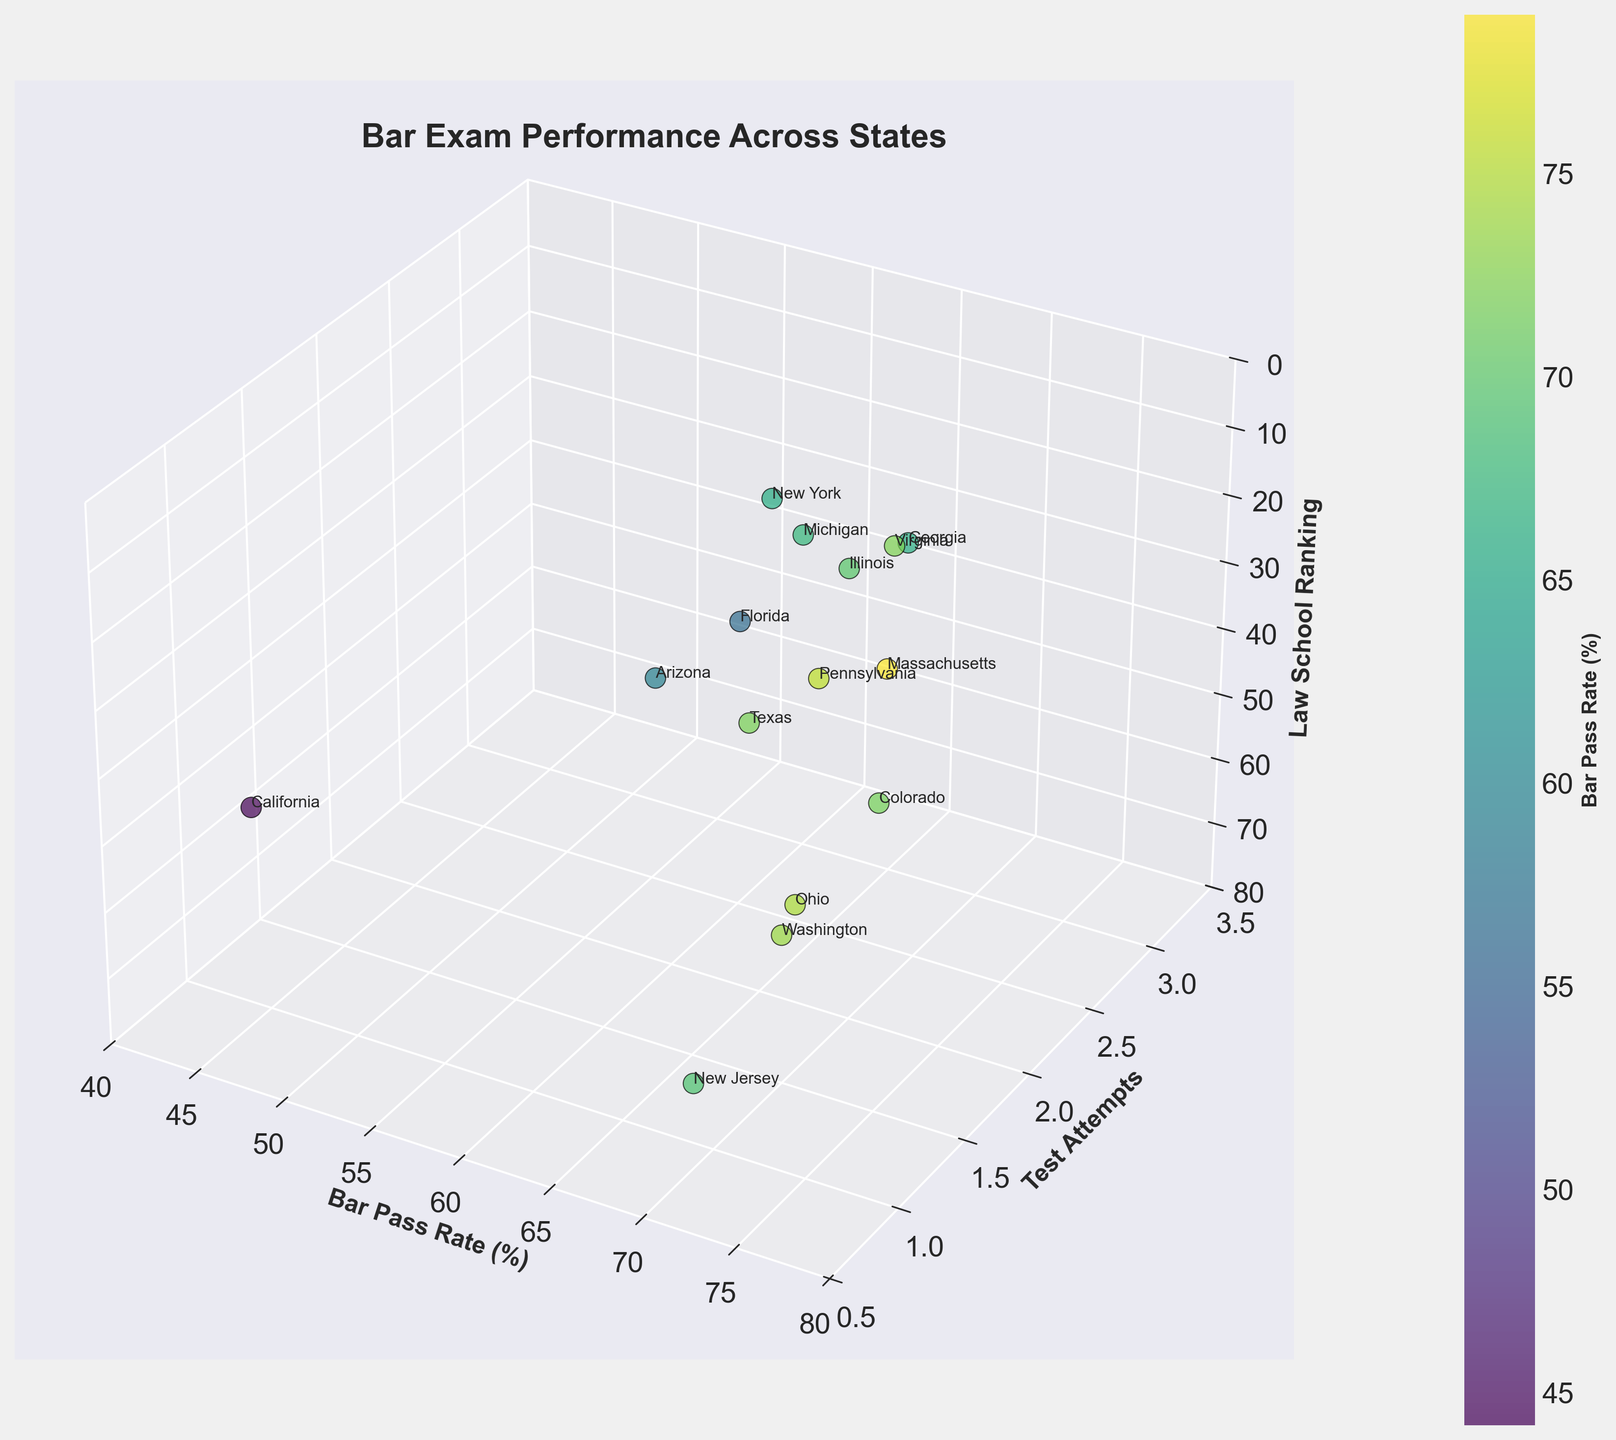What is the title of the plot? The title of the plot is displayed at the top of the figure. It describes what the figure is about.
Answer: Bar Exam Performance Across States Which axis represents the 'Test Attempts'? By observing the labels of the axes, we can determine that the axis labeled 'Test Attempts' represents the number of attempts taken for the bar exam.
Answer: The y-axis What is the Bar Pass Rate for Massachusetts? Look for the data point labeled 'Massachusetts' and observe its position on the x-axis, which represents the Bar Pass Rate.
Answer: 78.9% Which state has the highest Law School Ranking? The z-axis (Law School Ranking) is inverted (higher values are lower), so the state with the highest ranking will have the lowest value on this axis. Find the point with the lowest z-value on the inverted z-axis.
Answer: Massachusetts How many states have a Bar Pass Rate above 70%? Count the number of data points positioned above the 70% mark on the x-axis.
Answer: 7 Compare the Bar Pass Rate between Massachusetts and California. Which state performs better? Check the positions of Massachusetts and California on the x-axis. The state further to the right will have a higher Bar Pass Rate.
Answer: Massachusetts Among the states with 'Test Attempts' equal to 2, which has the lowest Law School Ranking? Filter the data points where the y-axis is set to 2 and identify the one with the lowest value on the inverted z-axis (Law School Ranking).
Answer: New York What is the average Bar Pass Rate of the states that attempted the exam more than once? Find the data points where the y-axis shows more than 1 attempt, sum their Bar Pass Rates, and divide by the number of those data points.
Answer: (65.5 + 69.7 + 72.1 + 67.2 + 59.1 + 71.5) / 6 = 67.5% Which state has the lowest Bar Pass Rate, and how many attempts did it take? Locate the data point with the lowest x-axis value (Bar Pass Rate) and check its y-axis value (Test Attempts) for the number of attempts.
Answer: California, 1 attempt For states with a Law School Ranking below 20, what is the range of their Bar Pass Rates? Identify data points where z-axis values are below 20, note their x-axis values (Bar Pass Rates), and calculate the difference between the highest and lowest Bar Pass Rates in this subset.
Answer: Range: 78.9% - 65.5% = 13.4% 